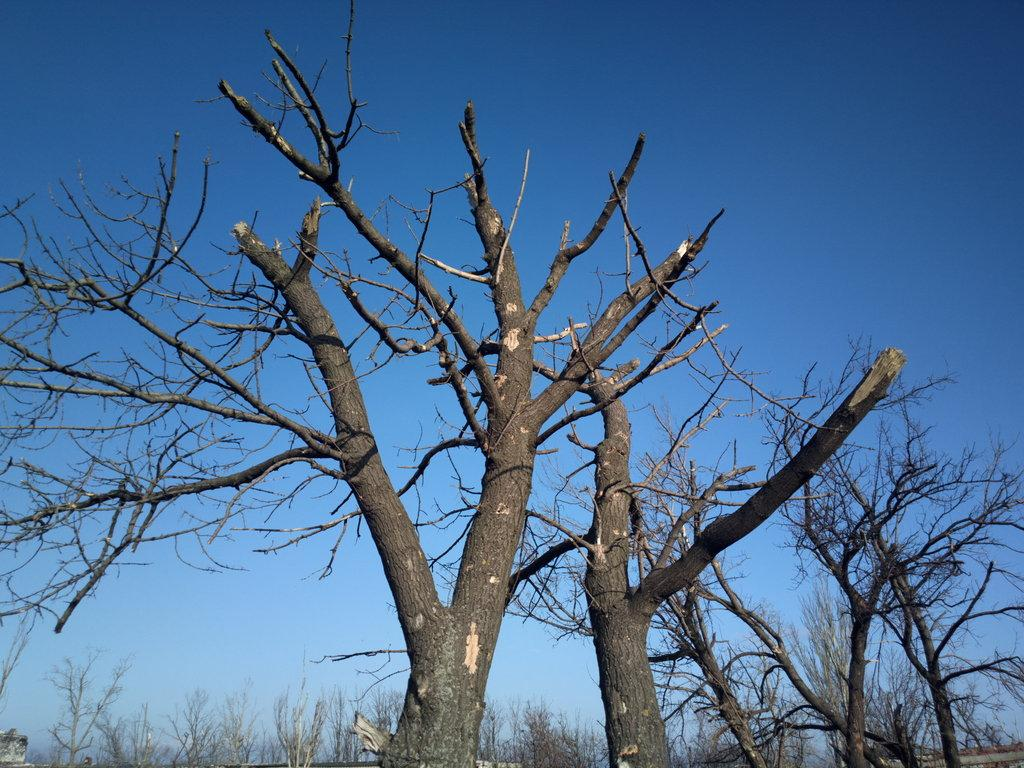What type of vegetation is visible in the foreground of the image? There are trees without leaves in the foreground of the image. What is visible at the top of the image? The sky is visible at the top of the image. Can you see any changes happening to the trees in the image? There is no indication of any changes happening to the trees in the image; they are simply trees without leaves. Is there a guitar visible in the image? There is no guitar present in the image. Where might someone place a basket in the image? There is no reference to a basket in the image, so it is not possible to determine where it might be placed. 